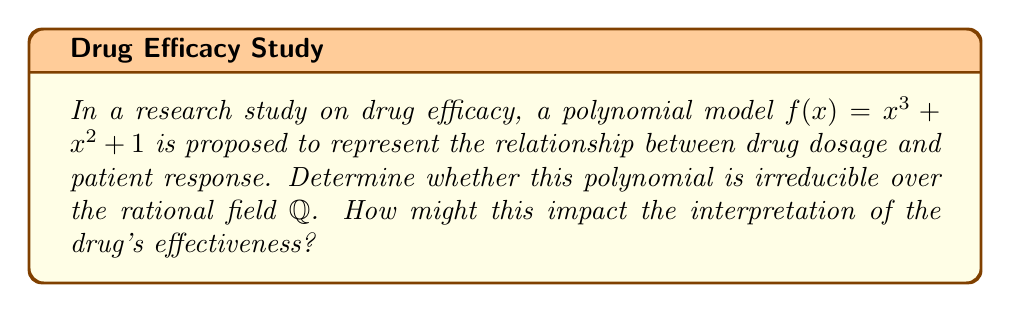Provide a solution to this math problem. To determine the irreducibility of $f(x) = x^3 + x^2 + 1$ over $\mathbb{Q}$, we can use the following steps:

1) First, check if there are any rational roots using the Rational Root Theorem. The possible rational roots are the factors of the constant term (1): $\pm 1$.

2) Evaluate $f(1)$ and $f(-1)$:
   $f(1) = 1^3 + 1^2 + 1 = 3 \neq 0$
   $f(-1) = (-1)^3 + (-1)^2 + 1 = -1 + 1 + 1 = 1 \neq 0$

3) Since neither 1 nor -1 are roots, the polynomial has no linear factors over $\mathbb{Q}$.

4) The only other possibility for reducibility would be if $f(x)$ could be factored as a linear term times a quadratic term.

5) If such a factorization existed, it would be of the form:
   $x^3 + x^2 + 1 = (x + a)(x^2 + bx + c)$, where $a, b, c \in \mathbb{Q}$

6) Expanding the right side:
   $(x + a)(x^2 + bx + c) = x^3 + bx^2 + cx + ax^2 + abx + ac$
                           $= x^3 + (a+b)x^2 + (ab+c)x + ac$

7) Comparing coefficients with the original polynomial:
   $a + b = 1$
   $ab + c = 0$
   $ac = 1$

8) From the last equation, we can deduce that both $a$ and $c$ must be $\pm 1$, as they are rational and their product is 1.

9) However, no combination of $a, b, c \in \mathbb{Q}$ satisfies all these equations simultaneously.

Therefore, $f(x) = x^3 + x^2 + 1$ is irreducible over $\mathbb{Q}$.

Impact on interpretation: The irreducibility of this polynomial suggests that the relationship between drug dosage and patient response cannot be simplified into simpler rational components. This implies a complex, non-linear relationship that cannot be easily decomposed, which may complicate the analysis of the drug's effectiveness across different dosage levels.
Answer: $f(x) = x^3 + x^2 + 1$ is irreducible over $\mathbb{Q}$ 